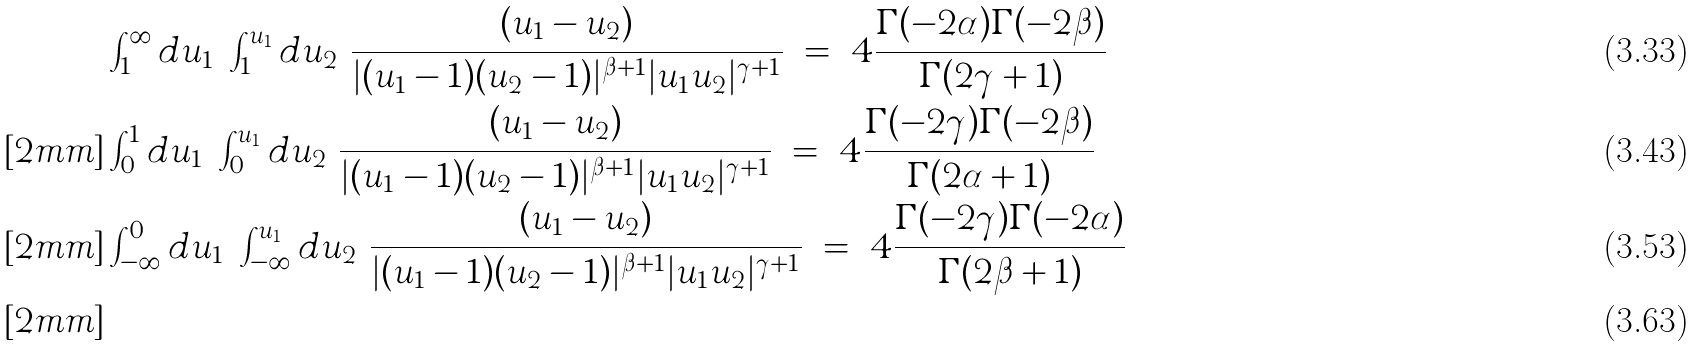Convert formula to latex. <formula><loc_0><loc_0><loc_500><loc_500>& \int _ { 1 } ^ { \infty } d u _ { 1 } \ \int _ { 1 } ^ { u _ { 1 } } d u _ { 2 } \ \frac { ( u _ { 1 } - u _ { 2 } ) } { | ( u _ { 1 } - 1 ) ( u _ { 2 } - 1 ) | ^ { \beta + 1 } | u _ { 1 } u _ { 2 } | ^ { \gamma + 1 } } \ = \ 4 \frac { \Gamma ( - 2 \alpha ) \Gamma ( - 2 \beta ) } { \Gamma ( 2 \gamma + 1 ) } \\ [ 2 m m ] & \int _ { 0 } ^ { 1 } d u _ { 1 } \ \int _ { 0 } ^ { u _ { 1 } } d u _ { 2 } \ \frac { ( u _ { 1 } - u _ { 2 } ) } { | ( u _ { 1 } - 1 ) ( u _ { 2 } - 1 ) | ^ { \beta + 1 } | u _ { 1 } u _ { 2 } | ^ { \gamma + 1 } } \ = \ 4 \frac { \Gamma ( - 2 \gamma ) \Gamma ( - 2 \beta ) } { \Gamma ( 2 \alpha + 1 ) } \\ [ 2 m m ] & \int _ { - \infty } ^ { 0 } d u _ { 1 } \ \int _ { - \infty } ^ { u _ { 1 } } d u _ { 2 } \ \frac { ( u _ { 1 } - u _ { 2 } ) } { | ( u _ { 1 } - 1 ) ( u _ { 2 } - 1 ) | ^ { \beta + 1 } | u _ { 1 } u _ { 2 } | ^ { \gamma + 1 } } \ = \ 4 \frac { \Gamma ( - 2 \gamma ) \Gamma ( - 2 \alpha ) } { \Gamma ( 2 \beta + 1 ) } \\ [ 2 m m ]</formula> 